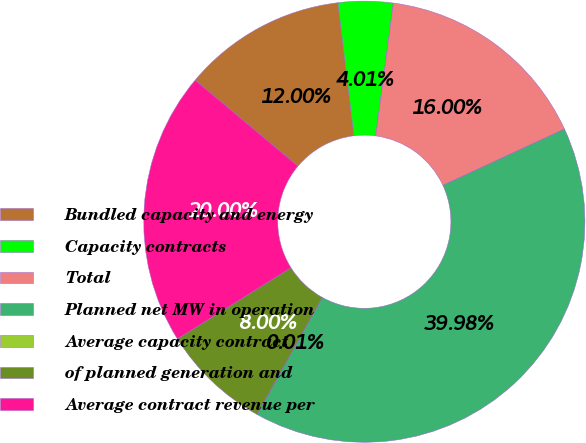<chart> <loc_0><loc_0><loc_500><loc_500><pie_chart><fcel>Bundled capacity and energy<fcel>Capacity contracts<fcel>Total<fcel>Planned net MW in operation<fcel>Average capacity contract<fcel>of planned generation and<fcel>Average contract revenue per<nl><fcel>12.0%<fcel>4.01%<fcel>16.0%<fcel>39.98%<fcel>0.01%<fcel>8.0%<fcel>20.0%<nl></chart> 